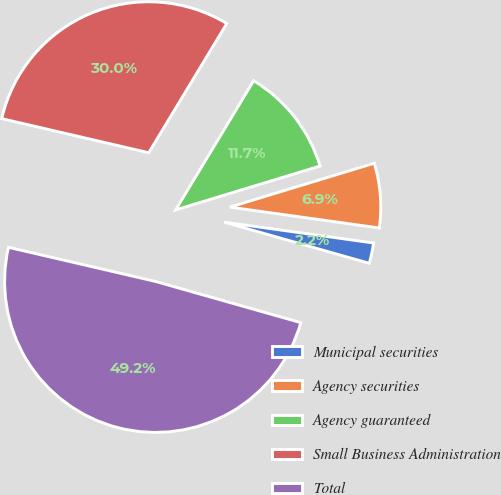Convert chart to OTSL. <chart><loc_0><loc_0><loc_500><loc_500><pie_chart><fcel>Municipal securities<fcel>Agency securities<fcel>Agency guaranteed<fcel>Small Business Administration<fcel>Total<nl><fcel>2.19%<fcel>6.9%<fcel>11.66%<fcel>30.02%<fcel>49.23%<nl></chart> 